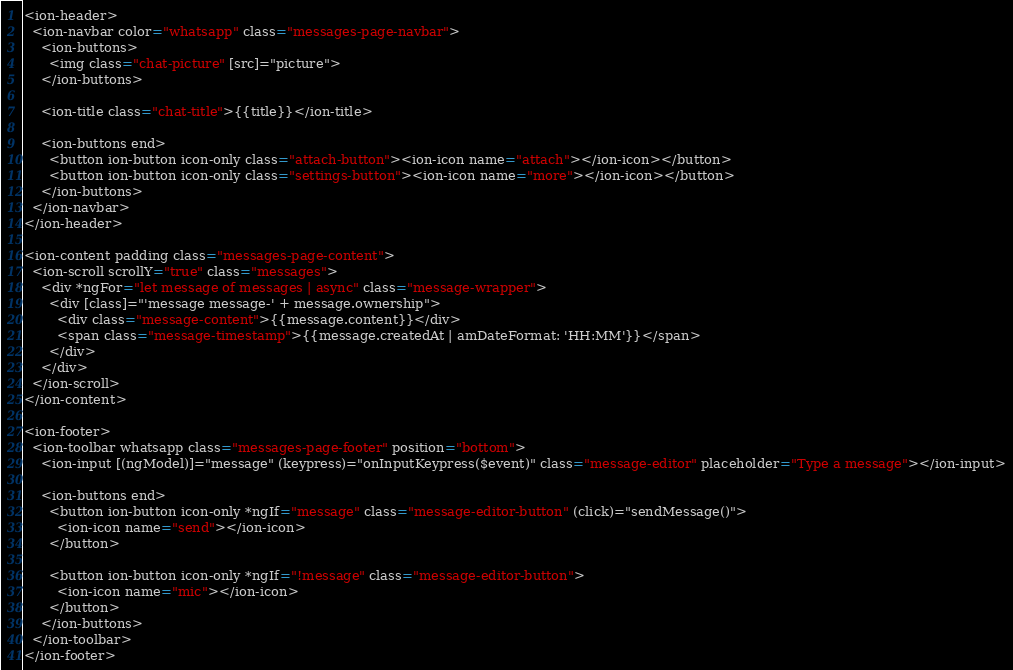<code> <loc_0><loc_0><loc_500><loc_500><_HTML_><ion-header>
  <ion-navbar color="whatsapp" class="messages-page-navbar">
    <ion-buttons>
      <img class="chat-picture" [src]="picture">
    </ion-buttons>

    <ion-title class="chat-title">{{title}}</ion-title>

    <ion-buttons end>
      <button ion-button icon-only class="attach-button"><ion-icon name="attach"></ion-icon></button>
      <button ion-button icon-only class="settings-button"><ion-icon name="more"></ion-icon></button>
    </ion-buttons>
  </ion-navbar>
</ion-header>

<ion-content padding class="messages-page-content">
  <ion-scroll scrollY="true" class="messages">
    <div *ngFor="let message of messages | async" class="message-wrapper">
      <div [class]="'message message-' + message.ownership">
        <div class="message-content">{{message.content}}</div>
        <span class="message-timestamp">{{message.createdAt | amDateFormat: 'HH:MM'}}</span>
      </div>
    </div>
  </ion-scroll>
</ion-content>

<ion-footer>
  <ion-toolbar whatsapp class="messages-page-footer" position="bottom">
    <ion-input [(ngModel)]="message" (keypress)="onInputKeypress($event)" class="message-editor" placeholder="Type a message"></ion-input>

    <ion-buttons end>
      <button ion-button icon-only *ngIf="message" class="message-editor-button" (click)="sendMessage()">
        <ion-icon name="send"></ion-icon>
      </button>

      <button ion-button icon-only *ngIf="!message" class="message-editor-button">
        <ion-icon name="mic"></ion-icon>
      </button>
    </ion-buttons>
  </ion-toolbar>
</ion-footer>
</code> 